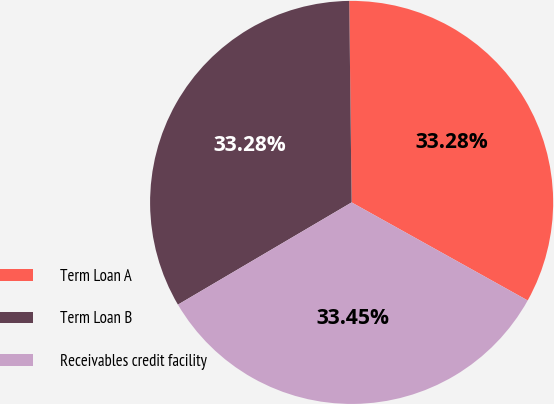Convert chart to OTSL. <chart><loc_0><loc_0><loc_500><loc_500><pie_chart><fcel>Term Loan A<fcel>Term Loan B<fcel>Receivables credit facility<nl><fcel>33.28%<fcel>33.28%<fcel>33.45%<nl></chart> 